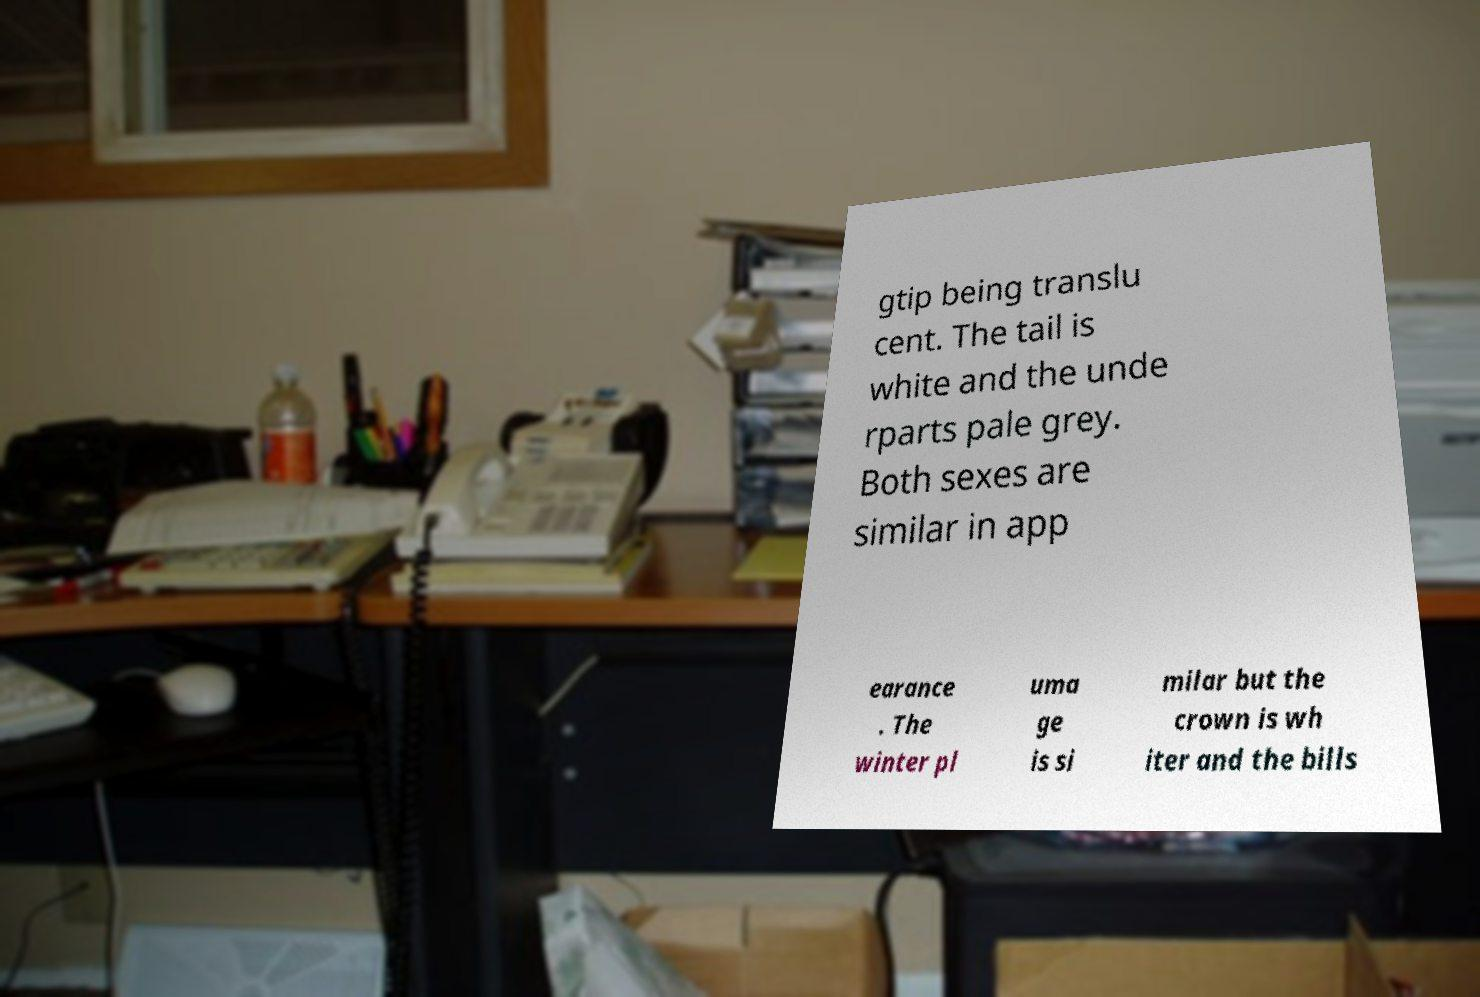There's text embedded in this image that I need extracted. Can you transcribe it verbatim? gtip being translu cent. The tail is white and the unde rparts pale grey. Both sexes are similar in app earance . The winter pl uma ge is si milar but the crown is wh iter and the bills 